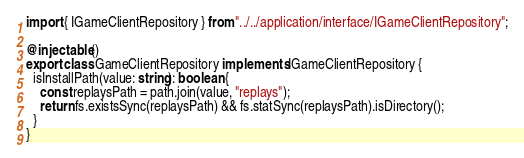<code> <loc_0><loc_0><loc_500><loc_500><_TypeScript_>import { IGameClientRepository } from "../../application/interface/IGameClientRepository";

@injectable()
export class GameClientRepository implements IGameClientRepository {
  isInstallPath(value: string): boolean {
    const replaysPath = path.join(value, "replays");
    return fs.existsSync(replaysPath) && fs.statSync(replaysPath).isDirectory();
  }
}
</code> 